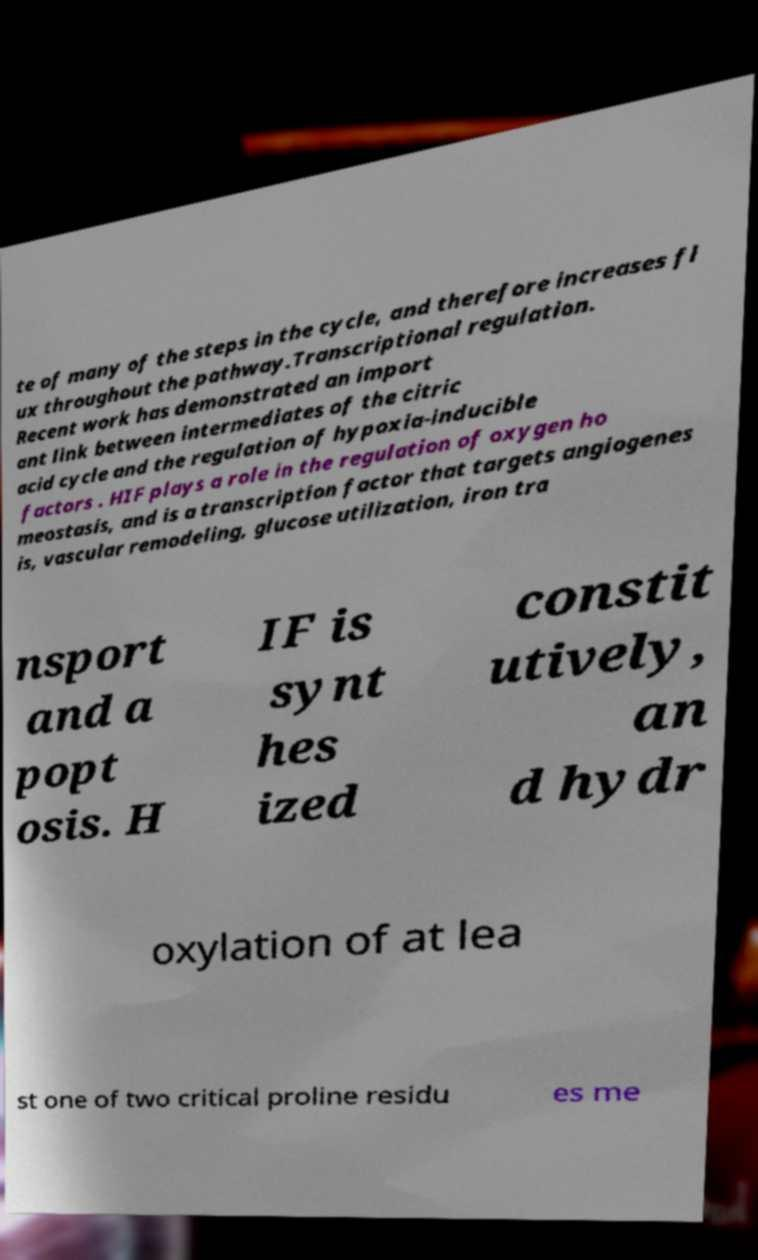Can you read and provide the text displayed in the image?This photo seems to have some interesting text. Can you extract and type it out for me? te of many of the steps in the cycle, and therefore increases fl ux throughout the pathway.Transcriptional regulation. Recent work has demonstrated an import ant link between intermediates of the citric acid cycle and the regulation of hypoxia-inducible factors . HIF plays a role in the regulation of oxygen ho meostasis, and is a transcription factor that targets angiogenes is, vascular remodeling, glucose utilization, iron tra nsport and a popt osis. H IF is synt hes ized constit utively, an d hydr oxylation of at lea st one of two critical proline residu es me 